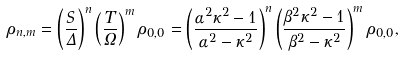<formula> <loc_0><loc_0><loc_500><loc_500>\rho _ { n , m } = \left ( \frac { S } { \Delta } \right ) ^ { n } \left ( \frac { T } { \Omega } \right ) ^ { m } \rho _ { 0 , 0 } = \left ( \frac { \alpha ^ { 2 } \kappa ^ { 2 } - 1 } { \alpha ^ { 2 } - \kappa ^ { 2 } } \right ) ^ { n } \left ( \frac { \beta ^ { 2 } \kappa ^ { 2 } - 1 } { \beta ^ { 2 } - \kappa ^ { 2 } } \right ) ^ { m } \rho _ { 0 , 0 } ,</formula> 